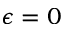Convert formula to latex. <formula><loc_0><loc_0><loc_500><loc_500>\epsilon = 0</formula> 